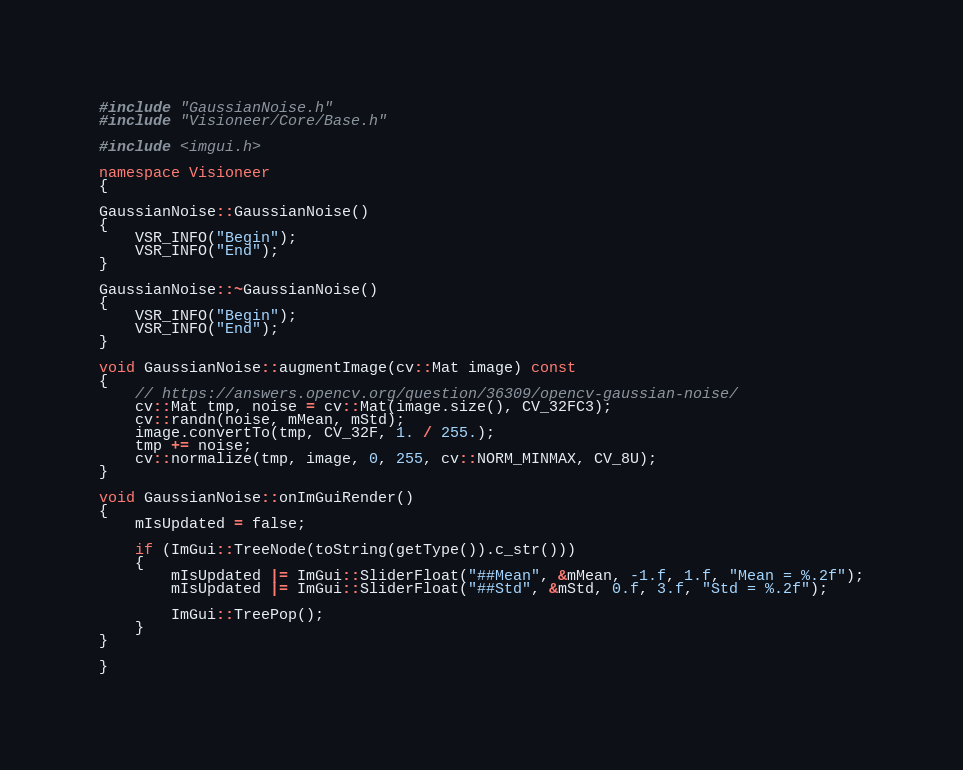Convert code to text. <code><loc_0><loc_0><loc_500><loc_500><_C++_>#include "GaussianNoise.h"
#include "Visioneer/Core/Base.h"

#include <imgui.h>

namespace Visioneer
{

GaussianNoise::GaussianNoise()
{
    VSR_INFO("Begin");
    VSR_INFO("End");
}

GaussianNoise::~GaussianNoise()
{
    VSR_INFO("Begin");
    VSR_INFO("End");
}

void GaussianNoise::augmentImage(cv::Mat image) const
{
    // https://answers.opencv.org/question/36309/opencv-gaussian-noise/
    cv::Mat tmp, noise = cv::Mat(image.size(), CV_32FC3);
    cv::randn(noise, mMean, mStd);
    image.convertTo(tmp, CV_32F, 1. / 255.);
    tmp += noise;
    cv::normalize(tmp, image, 0, 255, cv::NORM_MINMAX, CV_8U);
}

void GaussianNoise::onImGuiRender()
{
    mIsUpdated = false;

    if (ImGui::TreeNode(toString(getType()).c_str()))
    {
        mIsUpdated |= ImGui::SliderFloat("##Mean", &mMean, -1.f, 1.f, "Mean = %.2f");
        mIsUpdated |= ImGui::SliderFloat("##Std", &mStd, 0.f, 3.f, "Std = %.2f");

        ImGui::TreePop();
    }
}

}
</code> 